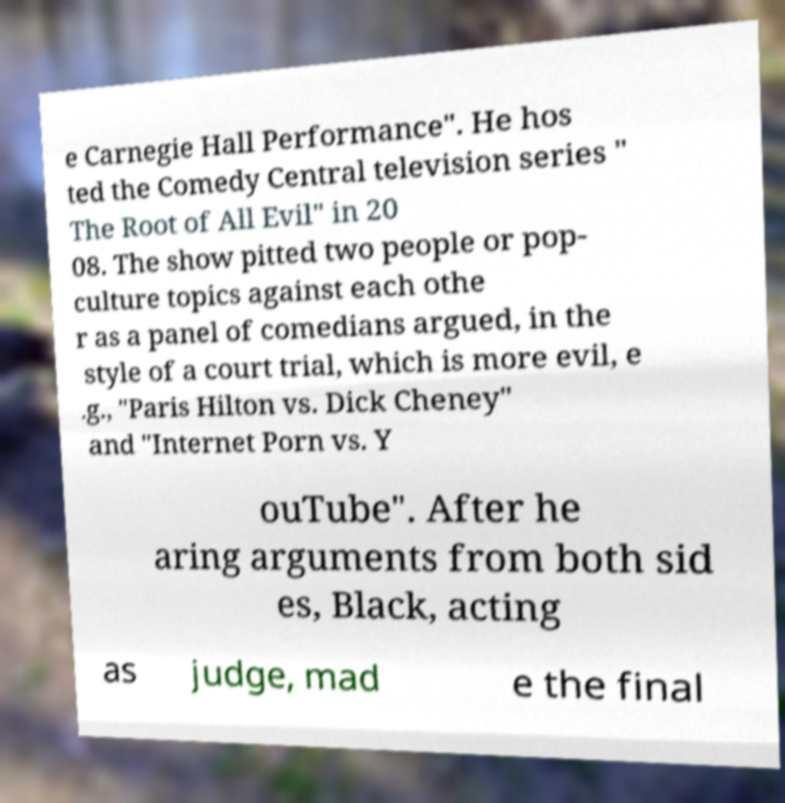I need the written content from this picture converted into text. Can you do that? e Carnegie Hall Performance". He hos ted the Comedy Central television series " The Root of All Evil" in 20 08. The show pitted two people or pop- culture topics against each othe r as a panel of comedians argued, in the style of a court trial, which is more evil, e .g., "Paris Hilton vs. Dick Cheney" and "Internet Porn vs. Y ouTube". After he aring arguments from both sid es, Black, acting as judge, mad e the final 